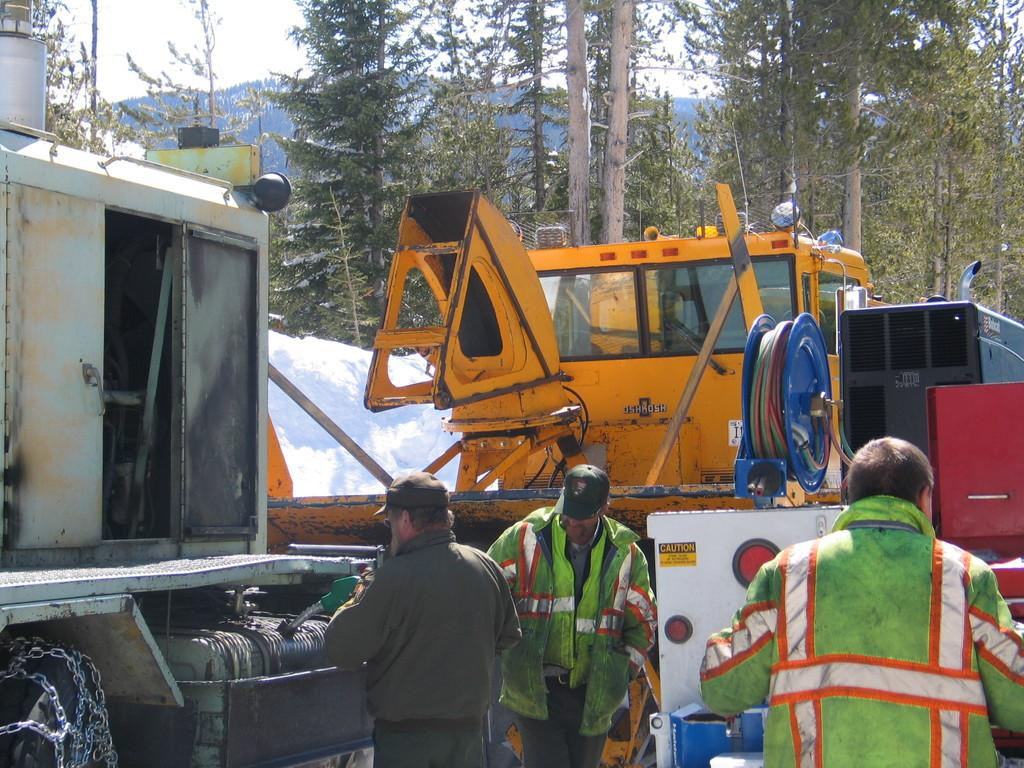What is located at the front of the image? There is a group of persons standing in the front of the image. What can be seen in the center of the image? There are vehicles in the center of the image. What type of natural scenery is visible in the background of the image? There are trees in the background of the image. Can you tell me how many bubbles are floating around the group of persons in the image? There are no bubbles present in the image; it features a group of persons, vehicles, and trees. What type of kitty can be seen playing with the vehicles in the image? There is no kitty present in the image; it features a group of persons, vehicles, and trees. 